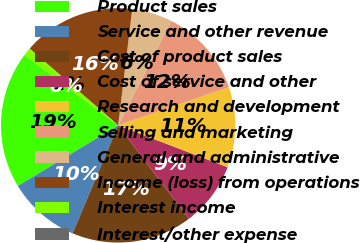Convert chart. <chart><loc_0><loc_0><loc_500><loc_500><pie_chart><fcel>Product sales<fcel>Service and other revenue<fcel>Cost of product sales<fcel>Cost of service and other<fcel>Research and development<fcel>Selling and marketing<fcel>General and administrative<fcel>Income (loss) from operations<fcel>Interest income<fcel>Interest/other expense<nl><fcel>18.88%<fcel>10.0%<fcel>16.66%<fcel>8.89%<fcel>11.11%<fcel>12.22%<fcel>5.56%<fcel>15.55%<fcel>1.12%<fcel>0.01%<nl></chart> 